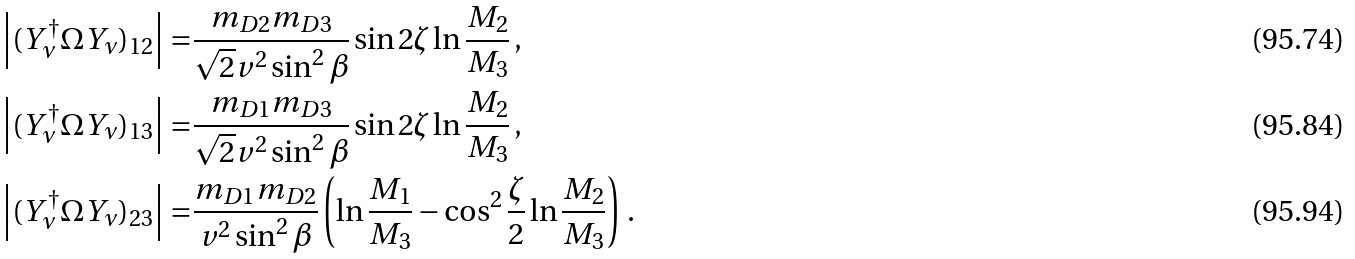Convert formula to latex. <formula><loc_0><loc_0><loc_500><loc_500>\left | ( Y _ { \nu } ^ { \dagger } \Omega Y _ { \nu } ) _ { 1 2 } \right | = & \frac { m _ { D 2 } m _ { D 3 } } { \sqrt { 2 } v ^ { 2 } \sin ^ { 2 } \beta } \sin 2 \zeta \ln \frac { M _ { 2 } } { M _ { 3 } } \, , \\ \left | ( Y _ { \nu } ^ { \dagger } \Omega Y _ { \nu } ) _ { 1 3 } \right | = & \frac { m _ { D 1 } m _ { D 3 } } { \sqrt { 2 } v ^ { 2 } \sin ^ { 2 } \beta } \sin 2 \zeta \ln \frac { M _ { 2 } } { M _ { 3 } } \, , \\ \left | ( Y _ { \nu } ^ { \dagger } \Omega Y _ { \nu } ) _ { 2 3 } \right | = & \frac { m _ { D 1 } m _ { D 2 } } { v ^ { 2 } \sin ^ { 2 } \beta } \left ( \ln \frac { M _ { 1 } } { M _ { 3 } } - \cos ^ { 2 } \frac { \zeta } { 2 } \ln \frac { M _ { 2 } } { M _ { 3 } } \right ) \, .</formula> 